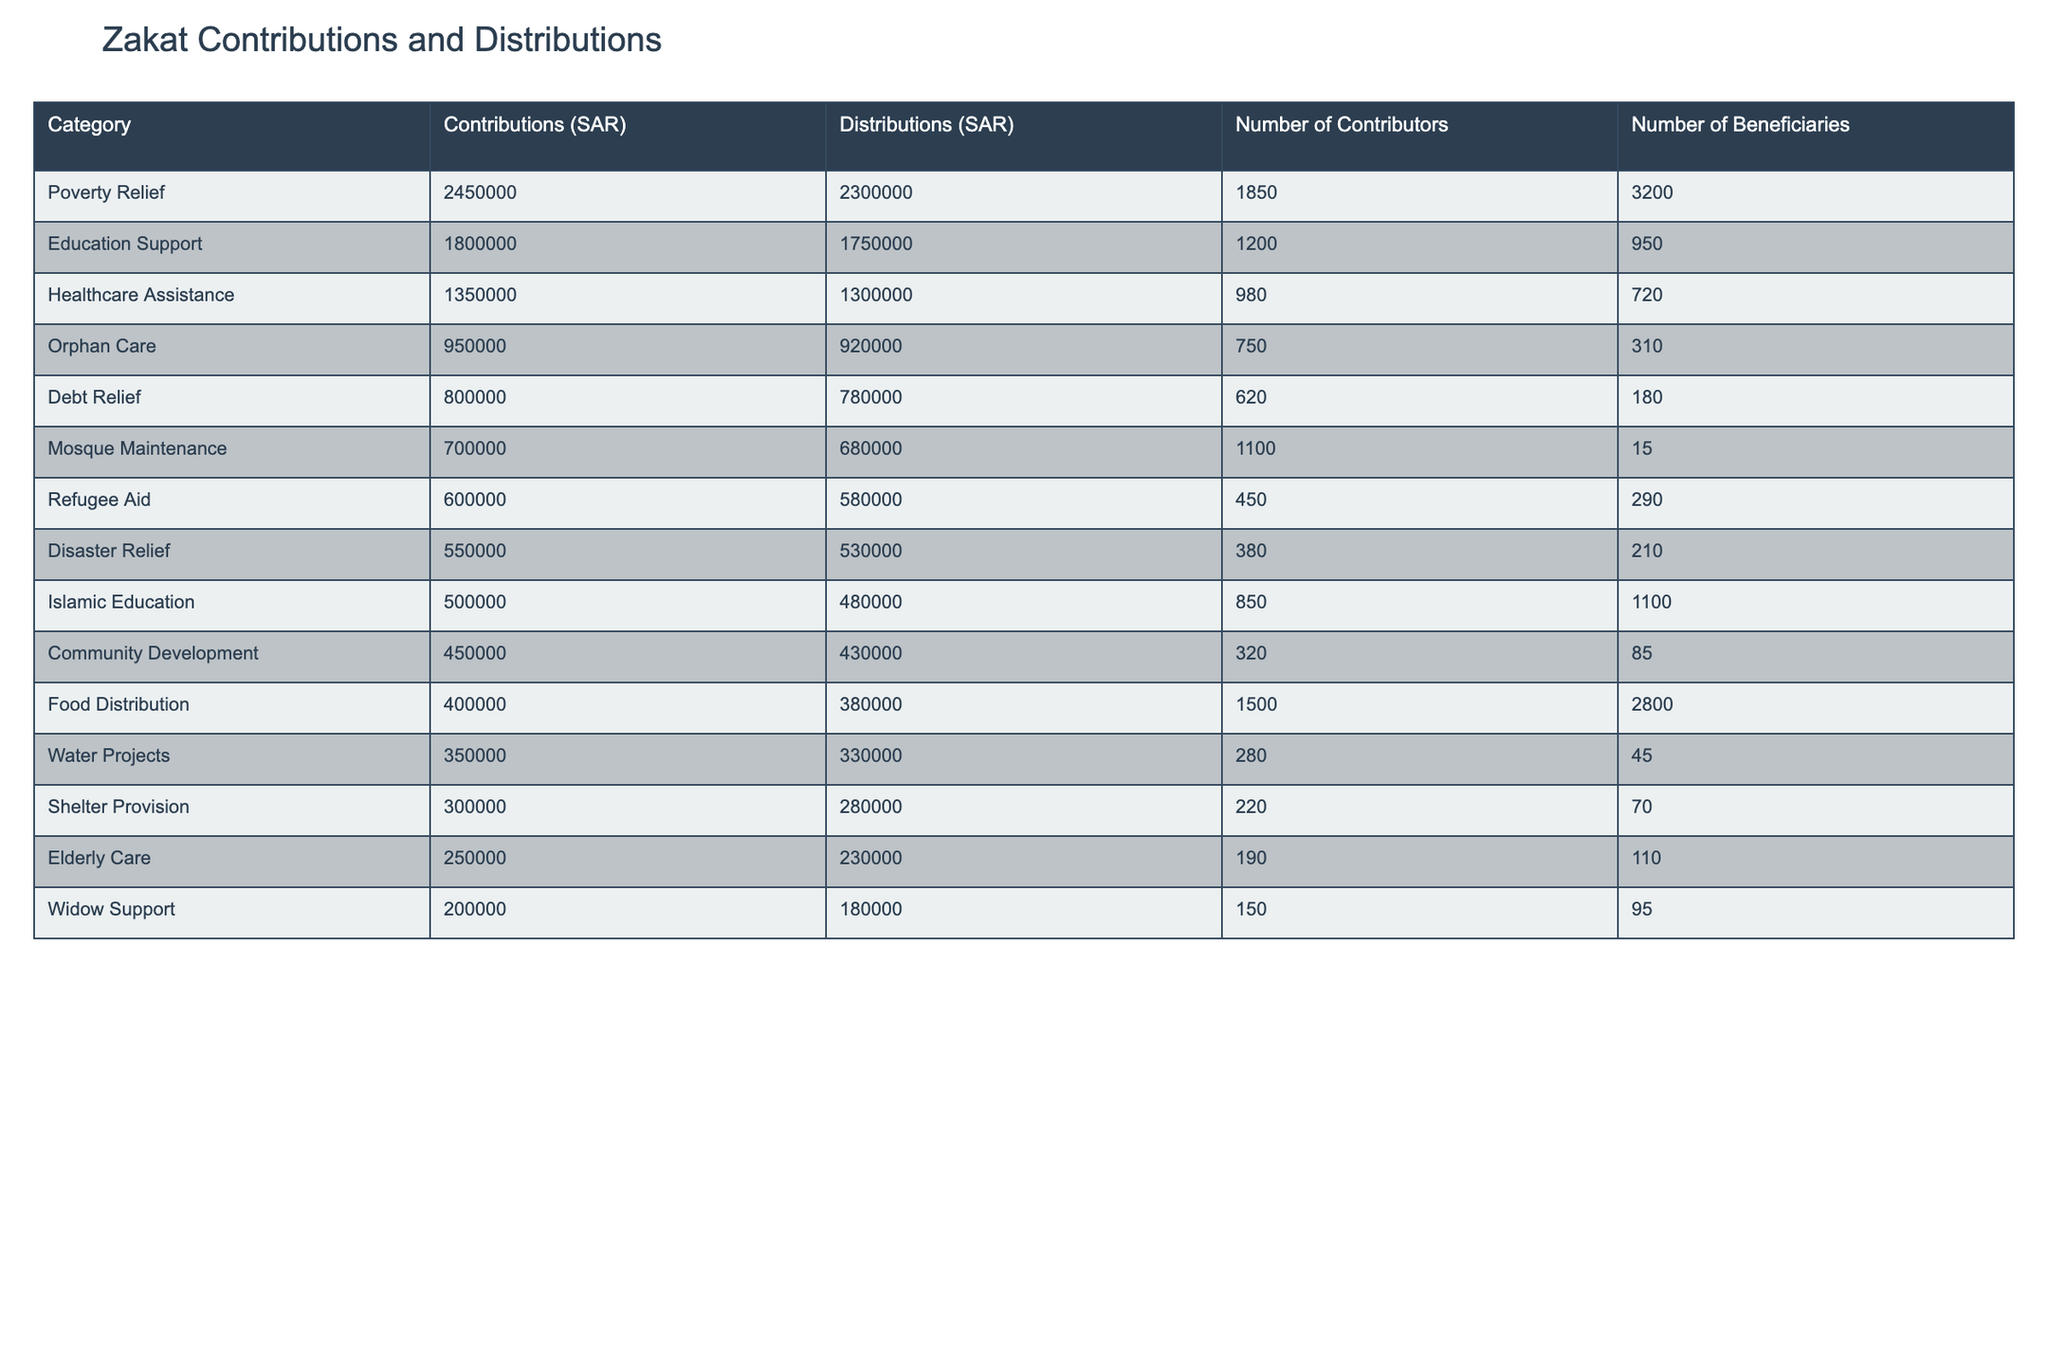What category received the highest contributions? By looking at the 'Contributions (SAR)' column, we can see that 'Poverty Relief' has the highest value at 2,450,000 SAR.
Answer: Poverty Relief How much was distributed for Education Support? The 'Distributions (SAR)' column indicates that 'Education Support' had a total distribution of 1,750,000 SAR.
Answer: 1,750,000 SAR What is the difference between contributions and distributions for Healthcare Assistance? The contributions for Healthcare Assistance are 1,350,000 SAR and distributions are 1,300,000 SAR. The difference is 1,350,000 - 1,300,000 = 50,000 SAR.
Answer: 50,000 SAR Which category had the lowest number of beneficiaries? The 'Number of Beneficiaries' for 'Mosque Maintenance' is the lowest at 15.
Answer: Mosque Maintenance What is the average contribution across all categories? Summing all the contributions gives 2,450,000 + 1,800,000 + 1,350,000 + 950,000 + 800,000 + 700,000 + 600,000 + 550,000 + 500,000 + 450,000 + 400,000 + 350,000 + 300,000 + 250,000 + 200,000 = 12,100,000 SAR. There are 15 categories, so the average contribution is 12,100,000 / 15 = 806,667 SAR.
Answer: 806,667 SAR Did the Orphan Care category receive more contributions than distributions? The contributions for Orphan Care are 950,000 SAR and distributions are 920,000 SAR. Since 950,000 is greater than 920,000, this is true.
Answer: Yes What percentage of contributions were distributed in the Food Distribution category? The total contributions in Food Distribution are 400,000 SAR and distributions are 380,000 SAR. The percentage is (380,000 / 400,000) * 100 = 95%.
Answer: 95% Which two categories had the highest number of contributors? Looking at the 'Number of Contributors' column, the highest values are for 'Poverty Relief' (1,850) and 'Food Distribution' (1,500).
Answer: Poverty Relief and Food Distribution What is the ratio of contributions to distributions for Shelter Provision? For Shelter Provision, contributions are 300,000 SAR and distributions are 280,000 SAR. Thus, the ratio is 300,000:280,000, which simplifies to 15:14.
Answer: 15:14 How many more contributors were there in Poverty Relief compared to Refugee Aid? The 'Number of Contributors' for Poverty Relief is 1,850 and for Refugee Aid is 450. The difference is 1,850 - 450 = 1,400.
Answer: 1,400 What is the total amount distributed for all categories combined? Summing the 'Distributions (SAR)' column gives us 2,300,000 + 1,750,000 + 1,300,000 + 920,000 + 780,000 + 680,000 + 580,000 + 530,000 + 480,000 + 430,000 + 380,000 + 330,000 + 280,000 + 230,000 + 180,000 = 12,200,000 SAR.
Answer: 12,200,000 SAR 